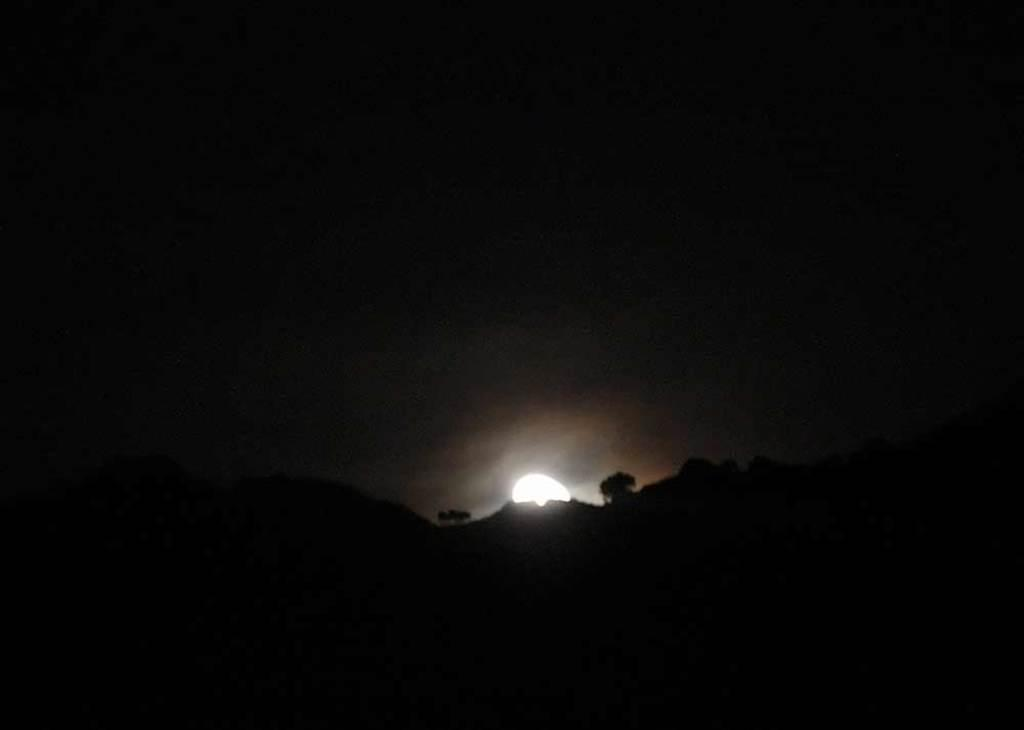What type of landscape feature is present in the image? There is a hill in the image. What other natural elements can be seen in the image? There are trees in the image. What celestial body is visible in the sky? The moon is visible in the sky. How would you describe the overall lighting in the image? The background of the image is dark. What type of knot is being used to secure the pump in the image? There is no pump or knot present in the image. What game is being played on the hill in the image? There is no game being played in the image; it only features a hill, trees, and the moon. 